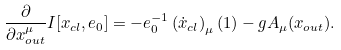Convert formula to latex. <formula><loc_0><loc_0><loc_500><loc_500>\frac { \partial } { \partial { x } _ { o u t } ^ { \mu } } I [ x _ { c l } , e _ { 0 } ] = - e _ { 0 } ^ { - 1 } \left ( \dot { x } _ { c l } \right ) _ { \mu } ( 1 ) - g A _ { \mu } ( x _ { o u t } ) .</formula> 